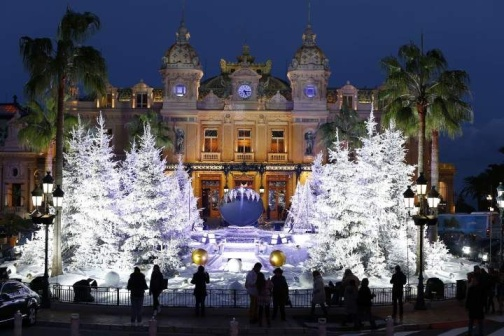What might a typical day in this scene look like? During the day, the grand building stands out as a busy hub, with people coming and going, attending to their daily business. The fountain, though not lit up, remains a focal point where tourists gather, children play, and locals relax. The palm trees provide shade, creating a pleasant atmosphere. Vendors might set up stalls selling local crafts and delicacies, adding a vibrant market feel. The area's beauty still stands out, but it's the hustle and bustle of everyday life that take center stage. 